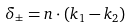<formula> <loc_0><loc_0><loc_500><loc_500>\delta _ { \pm } = { n } \cdot ( { k } _ { 1 } - { k } _ { 2 } )</formula> 